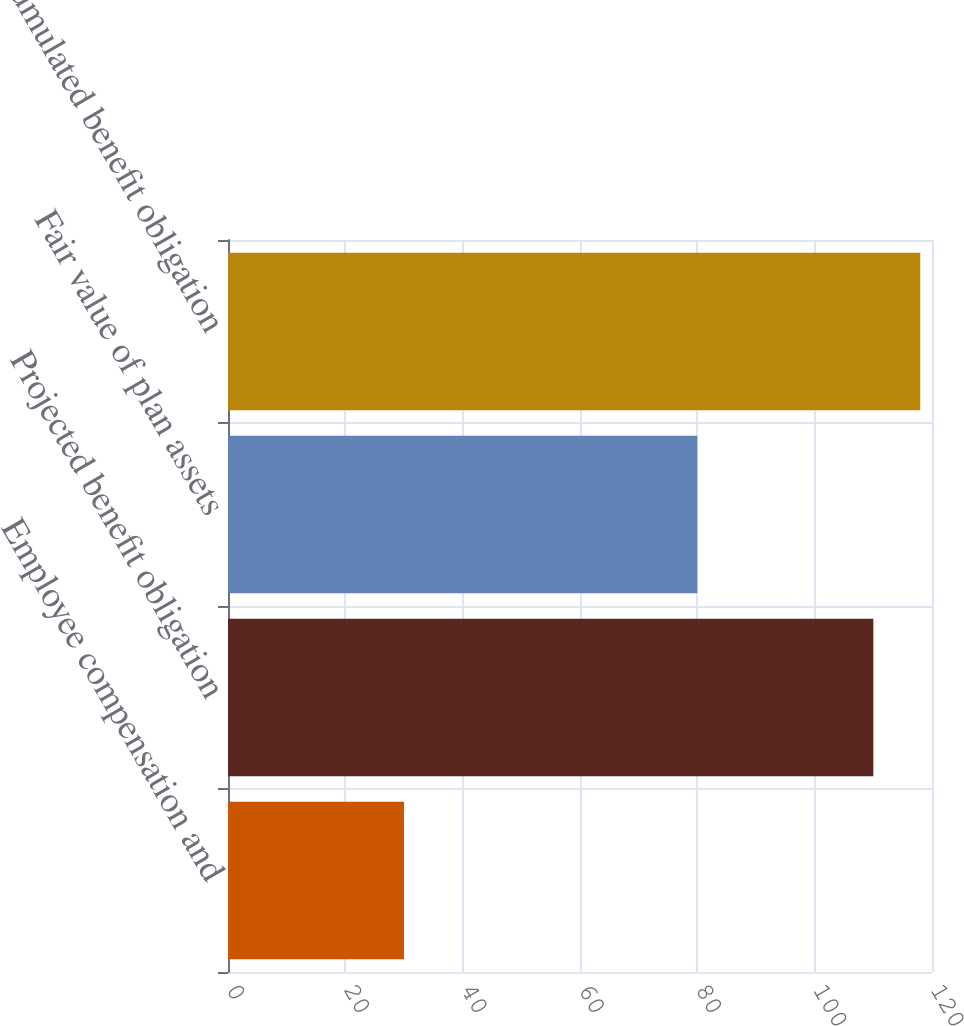<chart> <loc_0><loc_0><loc_500><loc_500><bar_chart><fcel>Employee compensation and<fcel>Projected benefit obligation<fcel>Fair value of plan assets<fcel>Accumulated benefit obligation<nl><fcel>30<fcel>110<fcel>80<fcel>118<nl></chart> 